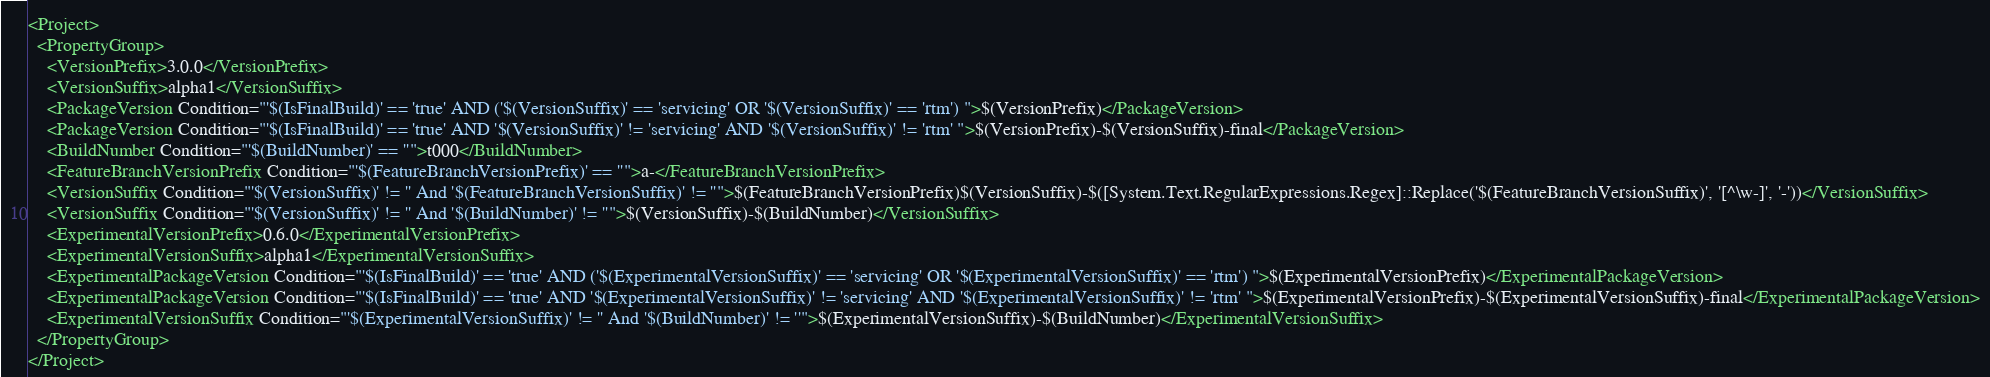Convert code to text. <code><loc_0><loc_0><loc_500><loc_500><_XML_><Project>
  <PropertyGroup>
    <VersionPrefix>3.0.0</VersionPrefix>
    <VersionSuffix>alpha1</VersionSuffix>
    <PackageVersion Condition="'$(IsFinalBuild)' == 'true' AND ('$(VersionSuffix)' == 'servicing' OR '$(VersionSuffix)' == 'rtm') ">$(VersionPrefix)</PackageVersion>
    <PackageVersion Condition="'$(IsFinalBuild)' == 'true' AND '$(VersionSuffix)' != 'servicing' AND '$(VersionSuffix)' != 'rtm' ">$(VersionPrefix)-$(VersionSuffix)-final</PackageVersion>
    <BuildNumber Condition="'$(BuildNumber)' == ''">t000</BuildNumber>
    <FeatureBranchVersionPrefix Condition="'$(FeatureBranchVersionPrefix)' == ''">a-</FeatureBranchVersionPrefix>
    <VersionSuffix Condition="'$(VersionSuffix)' != '' And '$(FeatureBranchVersionSuffix)' != ''">$(FeatureBranchVersionPrefix)$(VersionSuffix)-$([System.Text.RegularExpressions.Regex]::Replace('$(FeatureBranchVersionSuffix)', '[^\w-]', '-'))</VersionSuffix>
    <VersionSuffix Condition="'$(VersionSuffix)' != '' And '$(BuildNumber)' != ''">$(VersionSuffix)-$(BuildNumber)</VersionSuffix>
    <ExperimentalVersionPrefix>0.6.0</ExperimentalVersionPrefix>
    <ExperimentalVersionSuffix>alpha1</ExperimentalVersionSuffix>
    <ExperimentalPackageVersion Condition="'$(IsFinalBuild)' == 'true' AND ('$(ExperimentalVersionSuffix)' == 'servicing' OR '$(ExperimentalVersionSuffix)' == 'rtm') ">$(ExperimentalVersionPrefix)</ExperimentalPackageVersion>
    <ExperimentalPackageVersion Condition="'$(IsFinalBuild)' == 'true' AND '$(ExperimentalVersionSuffix)' != 'servicing' AND '$(ExperimentalVersionSuffix)' != 'rtm' ">$(ExperimentalVersionPrefix)-$(ExperimentalVersionSuffix)-final</ExperimentalPackageVersion>
    <ExperimentalVersionSuffix Condition="'$(ExperimentalVersionSuffix)' != '' And '$(BuildNumber)' != ''">$(ExperimentalVersionSuffix)-$(BuildNumber)</ExperimentalVersionSuffix>
  </PropertyGroup>
</Project>
</code> 